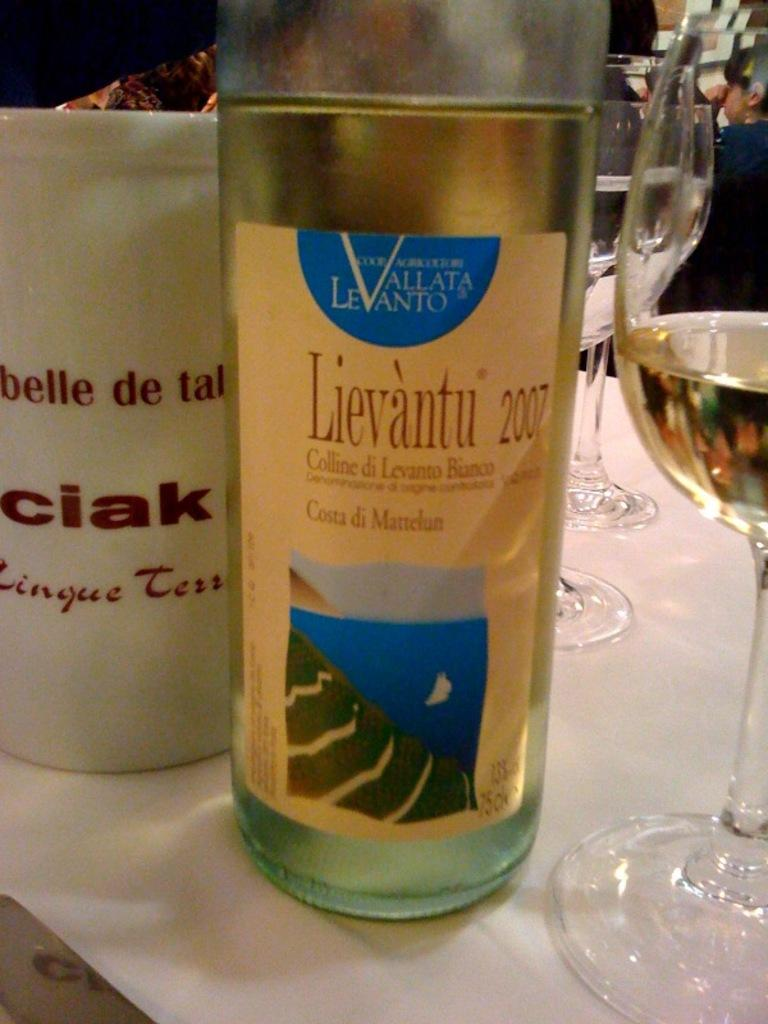What type of container is visible in the image? There is a bottle, a cup, and a glass with a drink in the image. What is the purpose of the glass with a drink? The glass with a drink is likely for consumption. Can you describe the person in the background of the image? Unfortunately, the facts provided do not give any details about the person in the background. How many containers are present in the image? There are three containers: a bottle, a cup, and a glass with a drink. What type of bike is being used to transport the growth in the image? There is no bike or growth present in the image. 